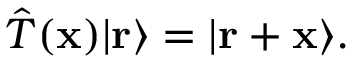<formula> <loc_0><loc_0><loc_500><loc_500>{ \hat { T } } ( x ) | r \rangle = | r + x \rangle .</formula> 